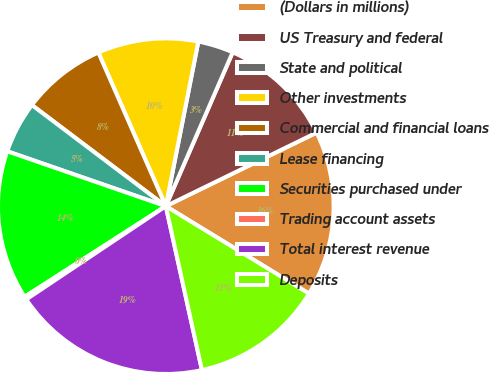<chart> <loc_0><loc_0><loc_500><loc_500><pie_chart><fcel>(Dollars in millions)<fcel>US Treasury and federal<fcel>State and political<fcel>Other investments<fcel>Commercial and financial loans<fcel>Lease financing<fcel>Securities purchased under<fcel>Trading account assets<fcel>Total interest revenue<fcel>Deposits<nl><fcel>15.95%<fcel>11.25%<fcel>3.42%<fcel>9.69%<fcel>8.12%<fcel>4.99%<fcel>14.39%<fcel>0.29%<fcel>19.08%<fcel>12.82%<nl></chart> 